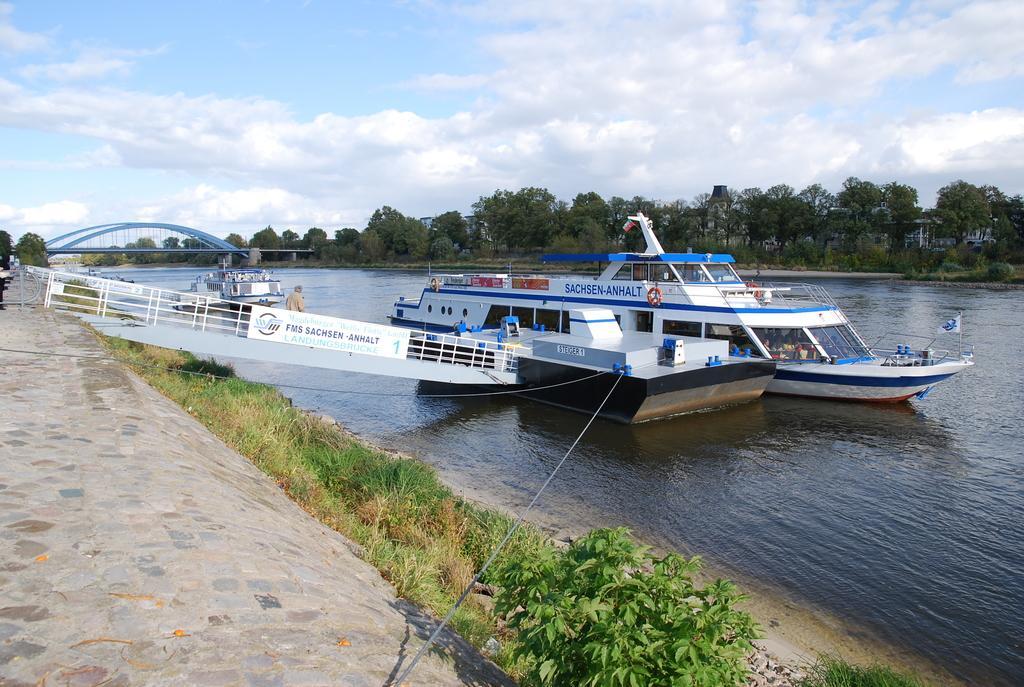Please provide a concise description of this image. In this image there is a bridge, arches, railings, boats, board, grass, plants, trees, cloudy sky, people, flag and objects. 